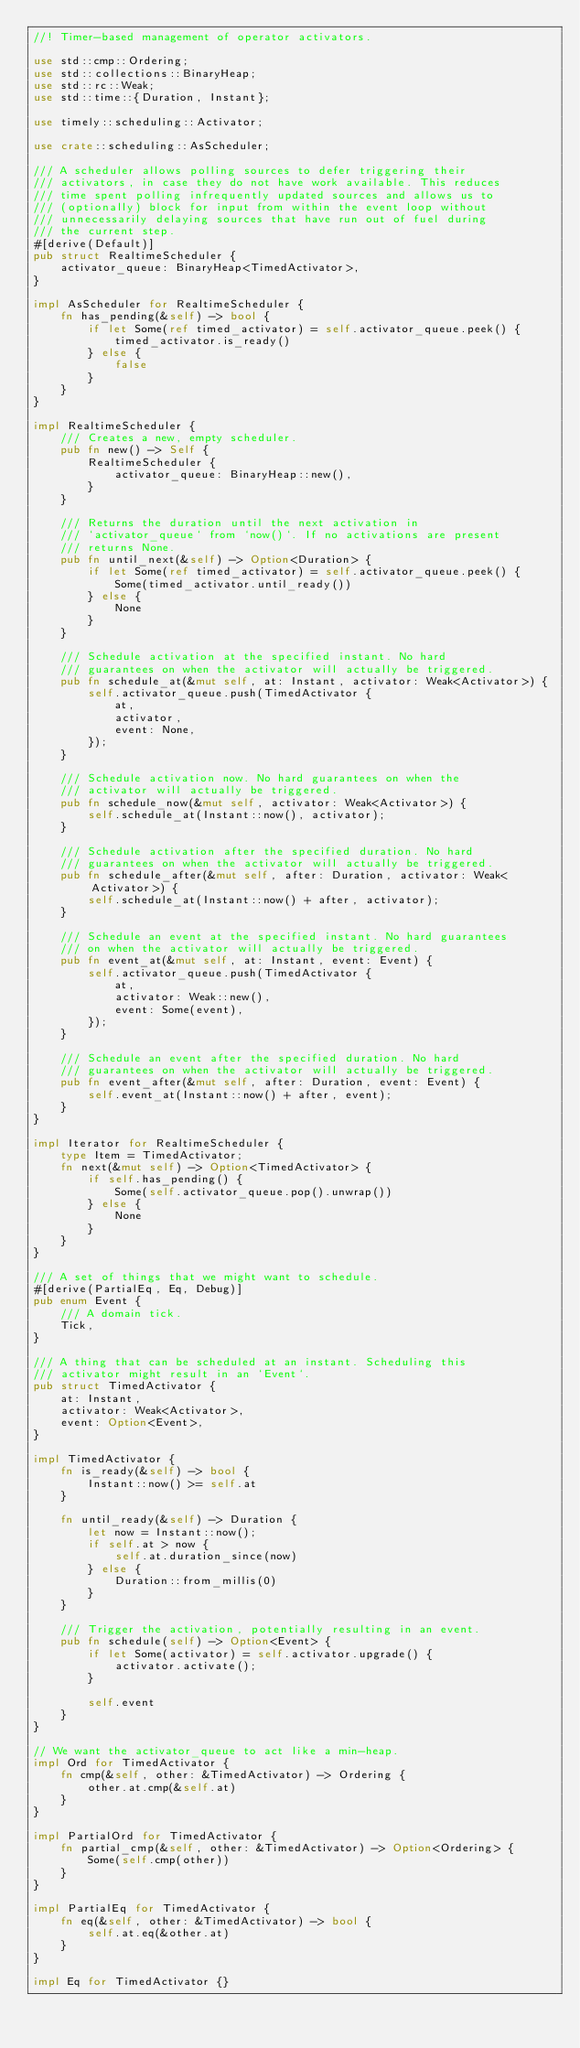Convert code to text. <code><loc_0><loc_0><loc_500><loc_500><_Rust_>//! Timer-based management of operator activators.

use std::cmp::Ordering;
use std::collections::BinaryHeap;
use std::rc::Weak;
use std::time::{Duration, Instant};

use timely::scheduling::Activator;

use crate::scheduling::AsScheduler;

/// A scheduler allows polling sources to defer triggering their
/// activators, in case they do not have work available. This reduces
/// time spent polling infrequently updated sources and allows us to
/// (optionally) block for input from within the event loop without
/// unnecessarily delaying sources that have run out of fuel during
/// the current step.
#[derive(Default)]
pub struct RealtimeScheduler {
    activator_queue: BinaryHeap<TimedActivator>,
}

impl AsScheduler for RealtimeScheduler {
    fn has_pending(&self) -> bool {
        if let Some(ref timed_activator) = self.activator_queue.peek() {
            timed_activator.is_ready()
        } else {
            false
        }
    }
}

impl RealtimeScheduler {
    /// Creates a new, empty scheduler.
    pub fn new() -> Self {
        RealtimeScheduler {
            activator_queue: BinaryHeap::new(),
        }
    }

    /// Returns the duration until the next activation in
    /// `activator_queue` from `now()`. If no activations are present
    /// returns None.
    pub fn until_next(&self) -> Option<Duration> {
        if let Some(ref timed_activator) = self.activator_queue.peek() {
            Some(timed_activator.until_ready())
        } else {
            None
        }
    }

    /// Schedule activation at the specified instant. No hard
    /// guarantees on when the activator will actually be triggered.
    pub fn schedule_at(&mut self, at: Instant, activator: Weak<Activator>) {
        self.activator_queue.push(TimedActivator {
            at,
            activator,
            event: None,
        });
    }

    /// Schedule activation now. No hard guarantees on when the
    /// activator will actually be triggered.
    pub fn schedule_now(&mut self, activator: Weak<Activator>) {
        self.schedule_at(Instant::now(), activator);
    }

    /// Schedule activation after the specified duration. No hard
    /// guarantees on when the activator will actually be triggered.
    pub fn schedule_after(&mut self, after: Duration, activator: Weak<Activator>) {
        self.schedule_at(Instant::now() + after, activator);
    }

    /// Schedule an event at the specified instant. No hard guarantees
    /// on when the activator will actually be triggered.
    pub fn event_at(&mut self, at: Instant, event: Event) {
        self.activator_queue.push(TimedActivator {
            at,
            activator: Weak::new(),
            event: Some(event),
        });
    }

    /// Schedule an event after the specified duration. No hard
    /// guarantees on when the activator will actually be triggered.
    pub fn event_after(&mut self, after: Duration, event: Event) {
        self.event_at(Instant::now() + after, event);
    }
}

impl Iterator for RealtimeScheduler {
    type Item = TimedActivator;
    fn next(&mut self) -> Option<TimedActivator> {
        if self.has_pending() {
            Some(self.activator_queue.pop().unwrap())
        } else {
            None
        }
    }
}

/// A set of things that we might want to schedule.
#[derive(PartialEq, Eq, Debug)]
pub enum Event {
    /// A domain tick.
    Tick,
}

/// A thing that can be scheduled at an instant. Scheduling this
/// activator might result in an `Event`.
pub struct TimedActivator {
    at: Instant,
    activator: Weak<Activator>,
    event: Option<Event>,
}

impl TimedActivator {
    fn is_ready(&self) -> bool {
        Instant::now() >= self.at
    }

    fn until_ready(&self) -> Duration {
        let now = Instant::now();
        if self.at > now {
            self.at.duration_since(now)
        } else {
            Duration::from_millis(0)
        }
    }

    /// Trigger the activation, potentially resulting in an event.
    pub fn schedule(self) -> Option<Event> {
        if let Some(activator) = self.activator.upgrade() {
            activator.activate();
        }

        self.event
    }
}

// We want the activator_queue to act like a min-heap.
impl Ord for TimedActivator {
    fn cmp(&self, other: &TimedActivator) -> Ordering {
        other.at.cmp(&self.at)
    }
}

impl PartialOrd for TimedActivator {
    fn partial_cmp(&self, other: &TimedActivator) -> Option<Ordering> {
        Some(self.cmp(other))
    }
}

impl PartialEq for TimedActivator {
    fn eq(&self, other: &TimedActivator) -> bool {
        self.at.eq(&other.at)
    }
}

impl Eq for TimedActivator {}
</code> 